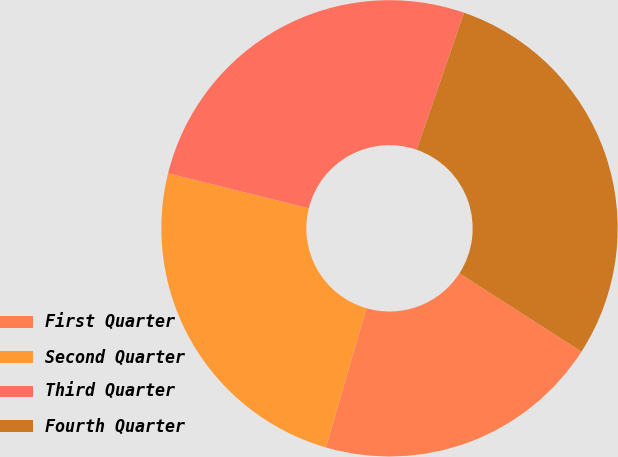<chart> <loc_0><loc_0><loc_500><loc_500><pie_chart><fcel>First Quarter<fcel>Second Quarter<fcel>Third Quarter<fcel>Fourth Quarter<nl><fcel>20.41%<fcel>24.38%<fcel>26.42%<fcel>28.79%<nl></chart> 